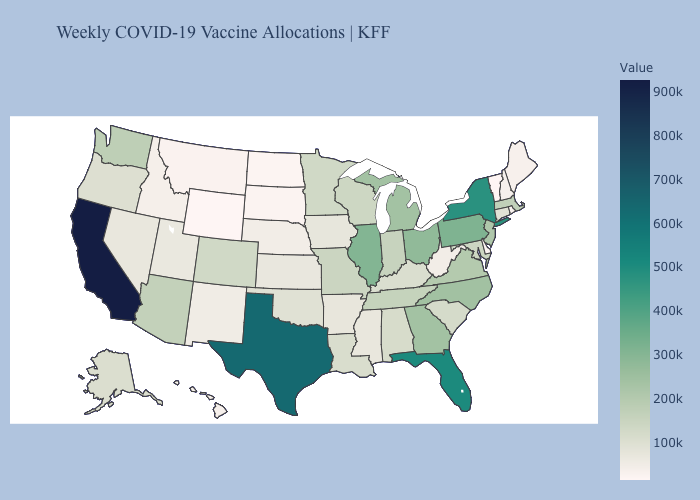Does Texas have the highest value in the USA?
Write a very short answer. No. Does North Dakota have the lowest value in the MidWest?
Concise answer only. Yes. Which states have the lowest value in the South?
Answer briefly. Delaware. Does Minnesota have a higher value than Georgia?
Concise answer only. No. Does California have the highest value in the West?
Give a very brief answer. Yes. Among the states that border Iowa , does South Dakota have the lowest value?
Give a very brief answer. Yes. Among the states that border West Virginia , which have the lowest value?
Keep it brief. Kentucky. Which states have the highest value in the USA?
Be succinct. California. 